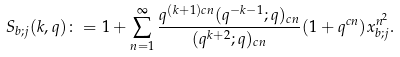<formula> <loc_0><loc_0><loc_500><loc_500>S _ { b ; j } ( k , q ) \colon = 1 + \sum _ { n = 1 } ^ { \infty } \frac { q ^ { ( k + 1 ) c n } ( q ^ { - k - 1 } ; q ) _ { c n } } { ( q ^ { k + 2 } ; q ) _ { c n } } ( 1 + q ^ { c n } ) x _ { b ; j } ^ { n ^ { 2 } } .</formula> 